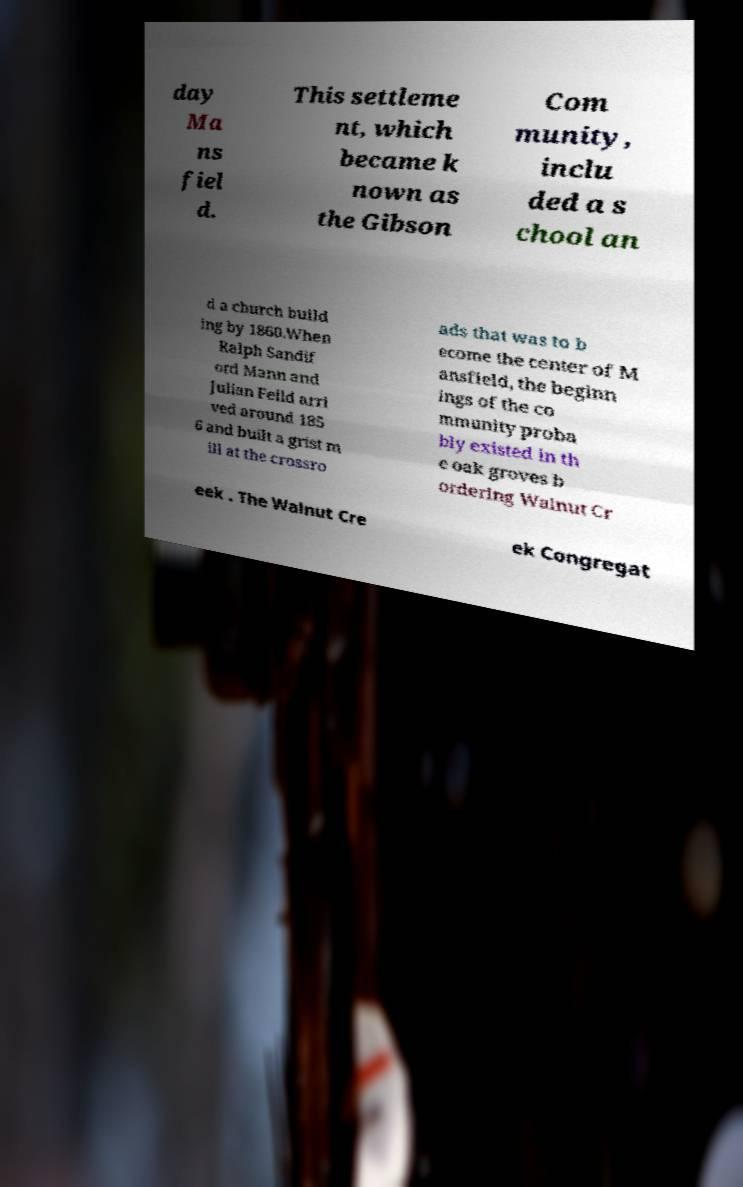Can you accurately transcribe the text from the provided image for me? day Ma ns fiel d. This settleme nt, which became k nown as the Gibson Com munity, inclu ded a s chool an d a church build ing by 1860.When Ralph Sandif ord Mann and Julian Feild arri ved around 185 6 and built a grist m ill at the crossro ads that was to b ecome the center of M ansfield, the beginn ings of the co mmunity proba bly existed in th e oak groves b ordering Walnut Cr eek . The Walnut Cre ek Congregat 